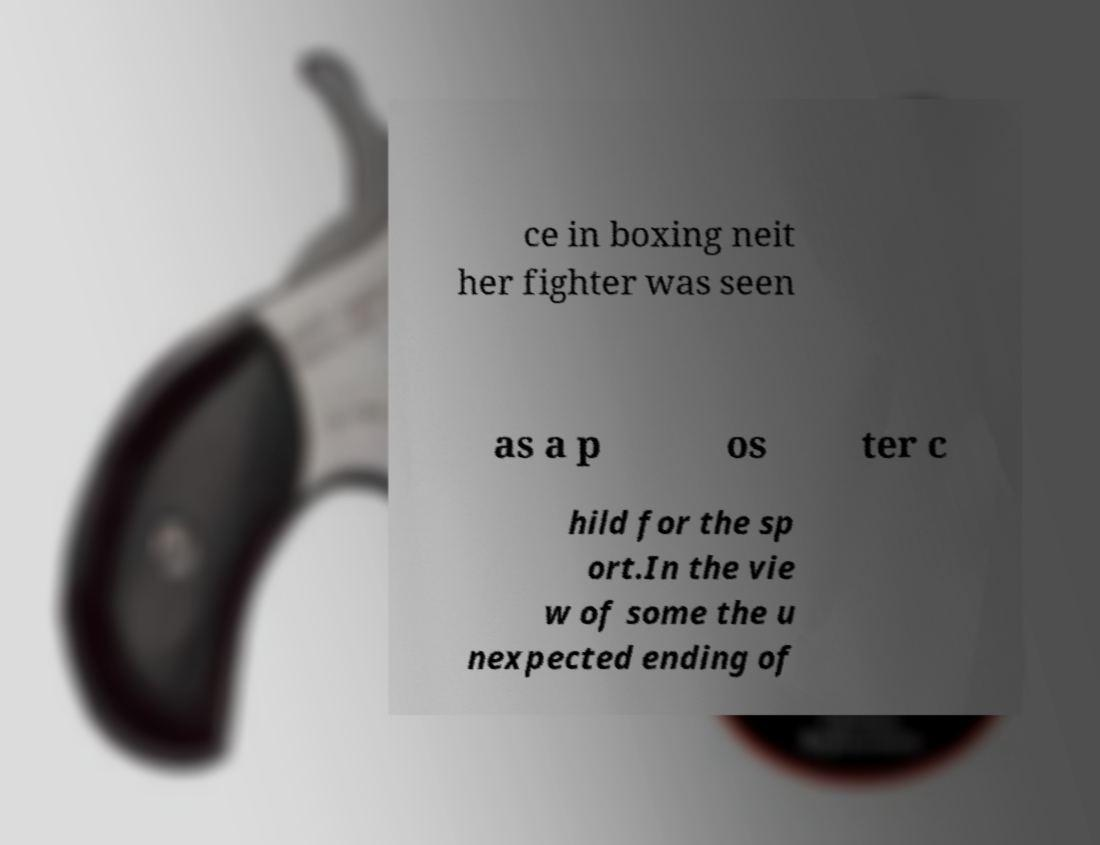Please read and relay the text visible in this image. What does it say? ce in boxing neit her fighter was seen as a p os ter c hild for the sp ort.In the vie w of some the u nexpected ending of 